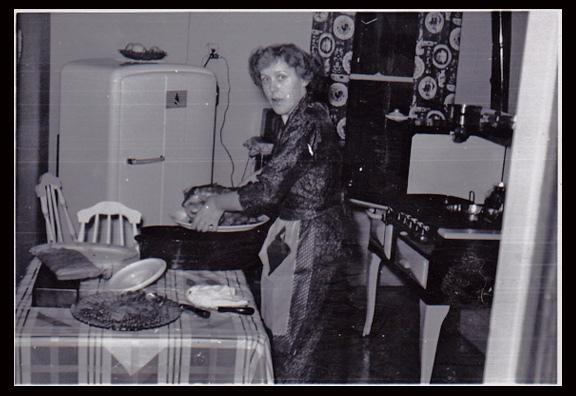What type of region is this likely? kitchen 